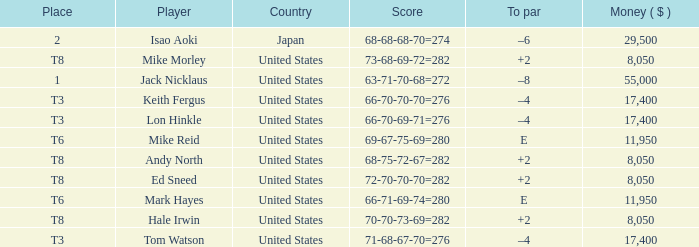What to par is located in the united states and has the player by the name of hale irwin? 2.0. 